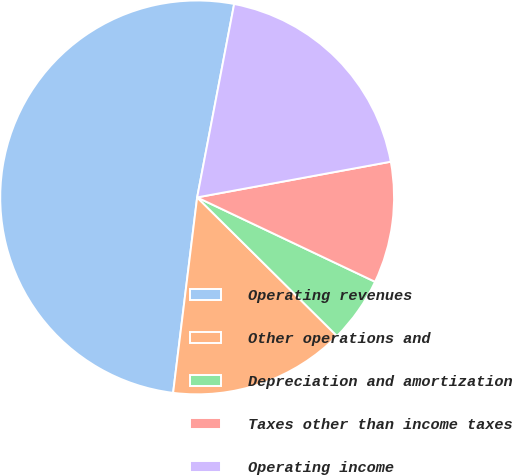Convert chart to OTSL. <chart><loc_0><loc_0><loc_500><loc_500><pie_chart><fcel>Operating revenues<fcel>Other operations and<fcel>Depreciation and amortization<fcel>Taxes other than income taxes<fcel>Operating income<nl><fcel>51.06%<fcel>14.52%<fcel>5.38%<fcel>9.95%<fcel>19.09%<nl></chart> 